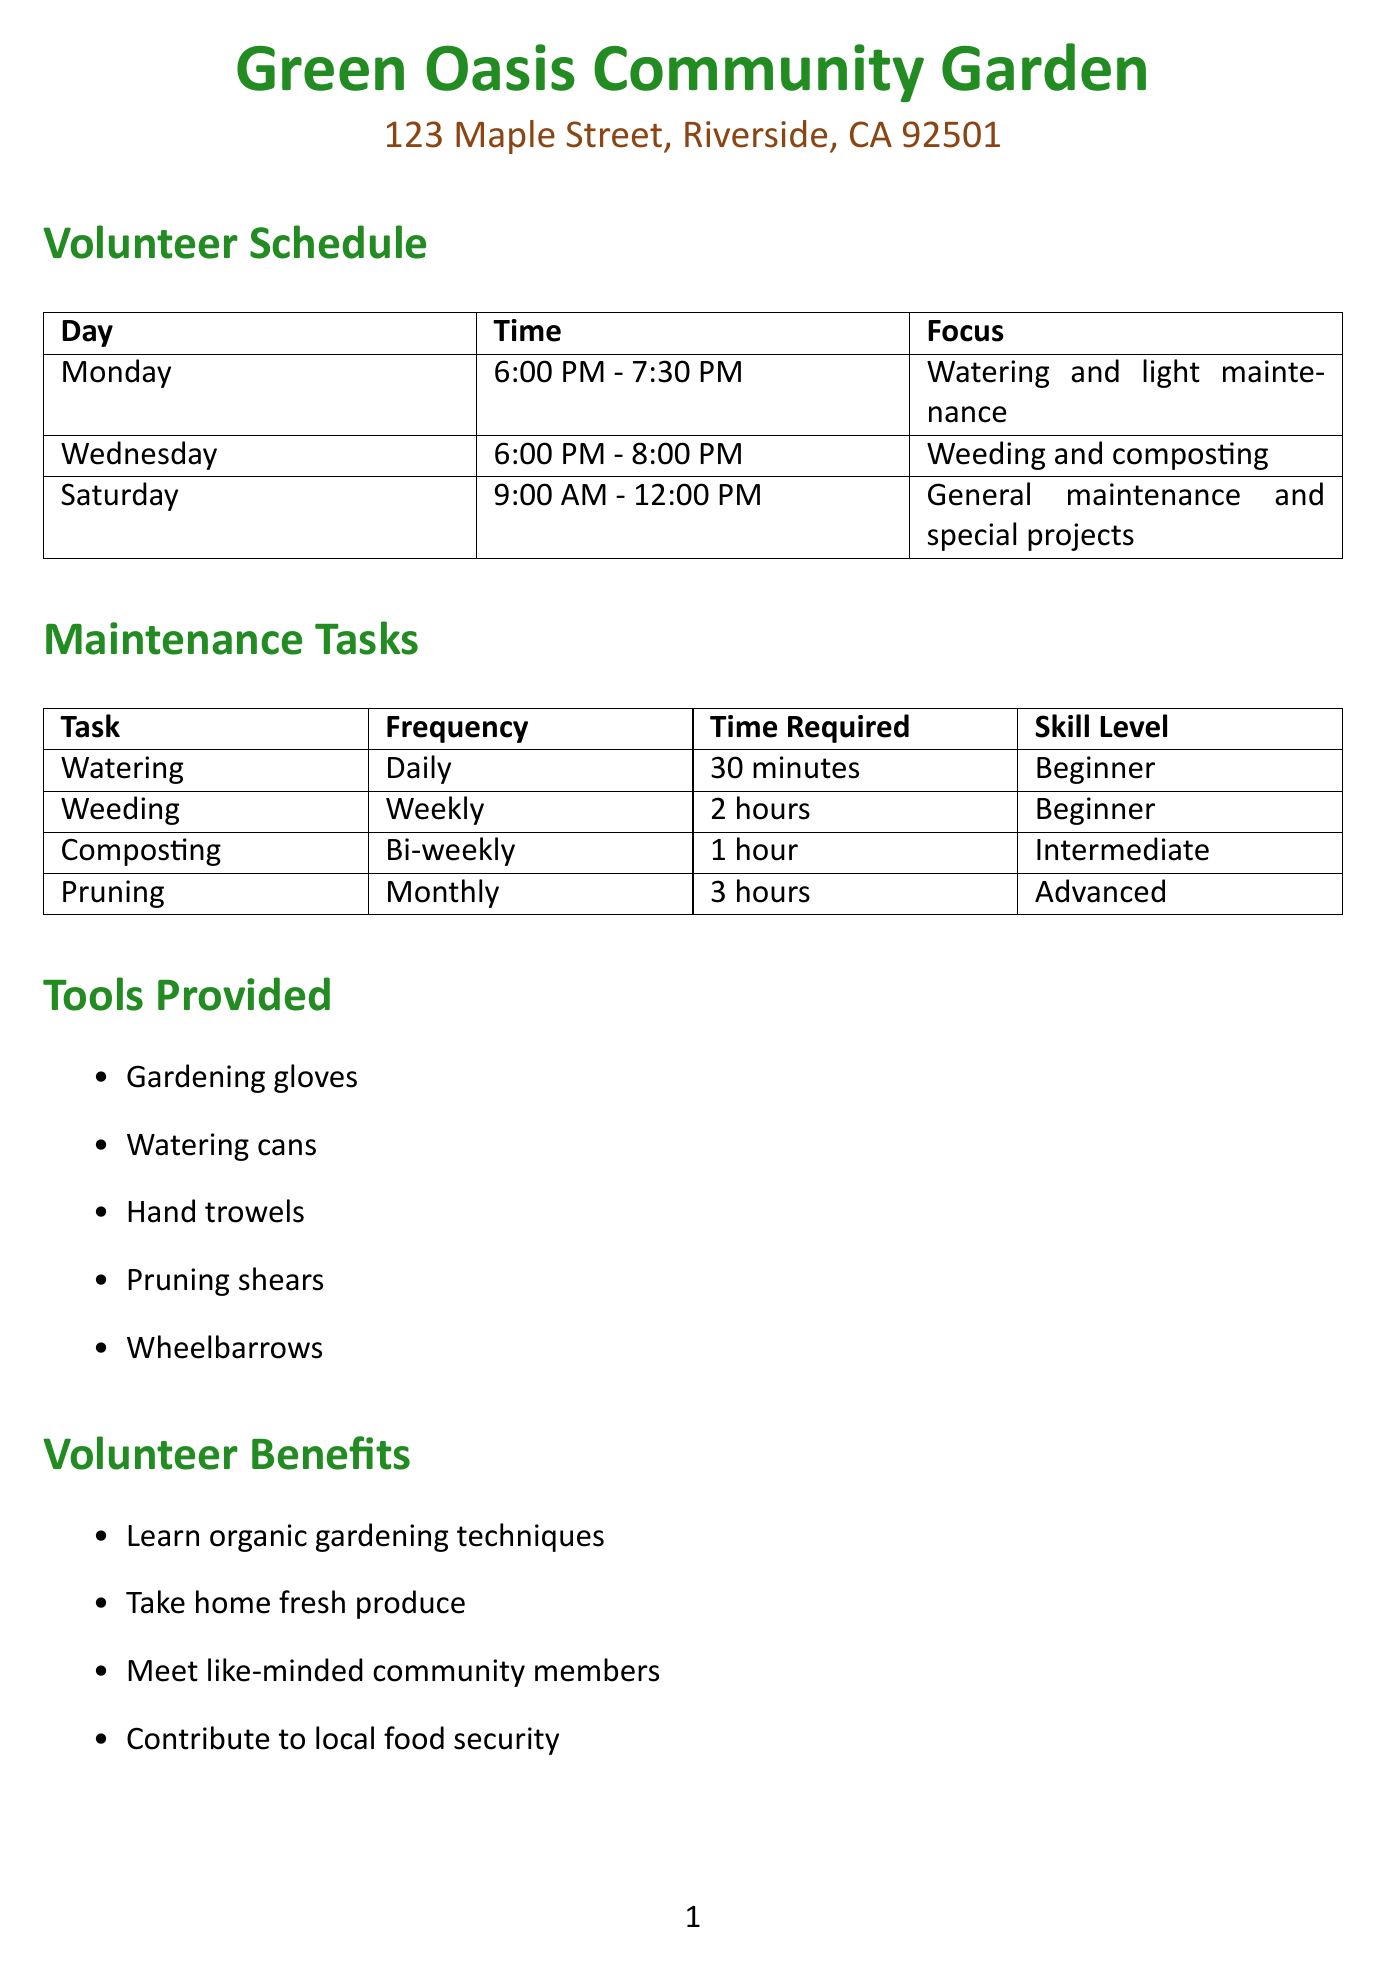What is the name of the community garden? The name of the community garden is stated clearly at the beginning of the document.
Answer: Green Oasis Community Garden Who is the volunteer coordinator? The document explicitly provides the name of the person responsible for coordinating volunteers.
Answer: Sarah Johnson What task is scheduled for Wednesdays? The document specifies the focus of the volunteer shifts for each day of the week, including Wednesday.
Answer: Weeding and composting How many hours are required for pruning each month? The time required for pruning is listed in the maintenance tasks section of the document.
Answer: 3 hours What is the date of the Harvest Festival? The document lists the special events along with their dates, including the Harvest Festival.
Answer: September 23, 2023 How often is composting scheduled? The frequency of composting is detailed in the maintenance tasks section, providing insight into how often this task occurs.
Answer: Bi-weekly What tools are provided for volunteers? The document includes a list of tools provided for volunteers, outlining the resources available to them.
Answer: Gardening gloves, Watering cans, Hand trowels, Pruning shears, Wheelbarrows What are two benefits of volunteering mentioned in the document? The benefits of volunteering are outlined in the volunteer benefits section, detailing what volunteers can gain from participation.
Answer: Learn organic gardening techniques, Take home fresh produce What is the primary focus of Saturday shifts? The document describes the focus of Saturday shifts in the volunteer schedule, giving insight into weekend activities.
Answer: General maintenance and special projects 